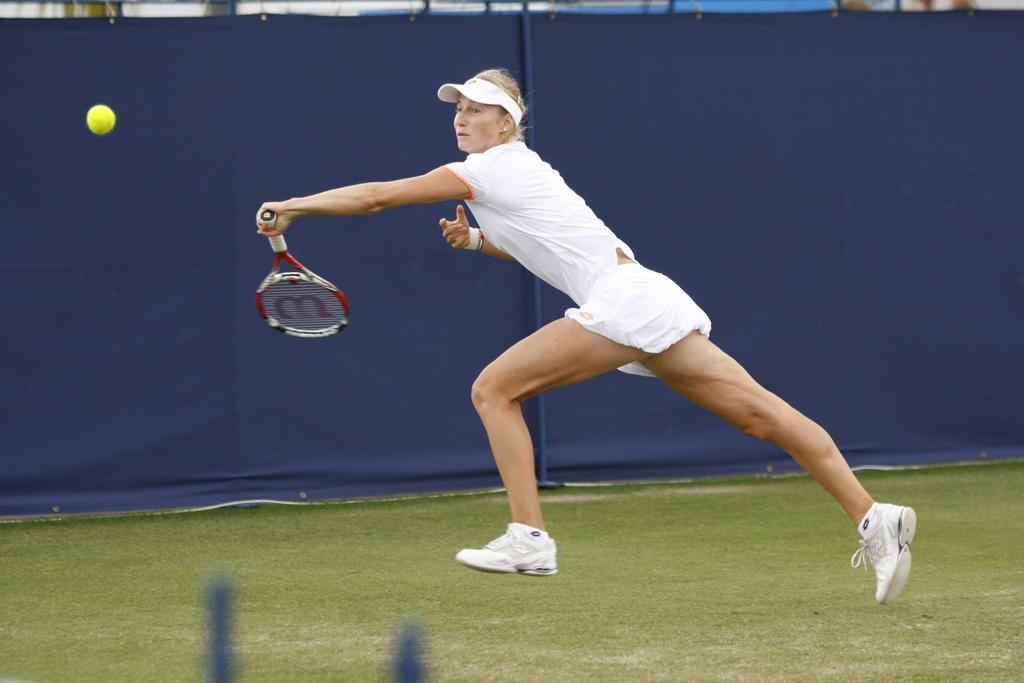Who is the main subject in the image? There is a woman in the image. What is the woman doing in the image? The woman is playing tennis. What can be seen in the background of the image? There is a banner in the background of the image. What type of shoes is the carpenter wearing in the image? There is no carpenter present in the image, and therefore no shoes to describe. 